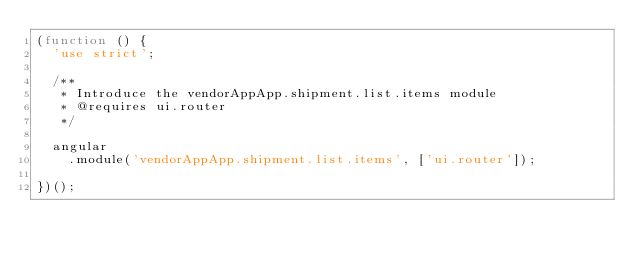<code> <loc_0><loc_0><loc_500><loc_500><_JavaScript_>(function () {
  'use strict';

  /**
   * Introduce the vendorAppApp.shipment.list.items module
   * @requires ui.router
   */

  angular
    .module('vendorAppApp.shipment.list.items', ['ui.router']);

})();
</code> 